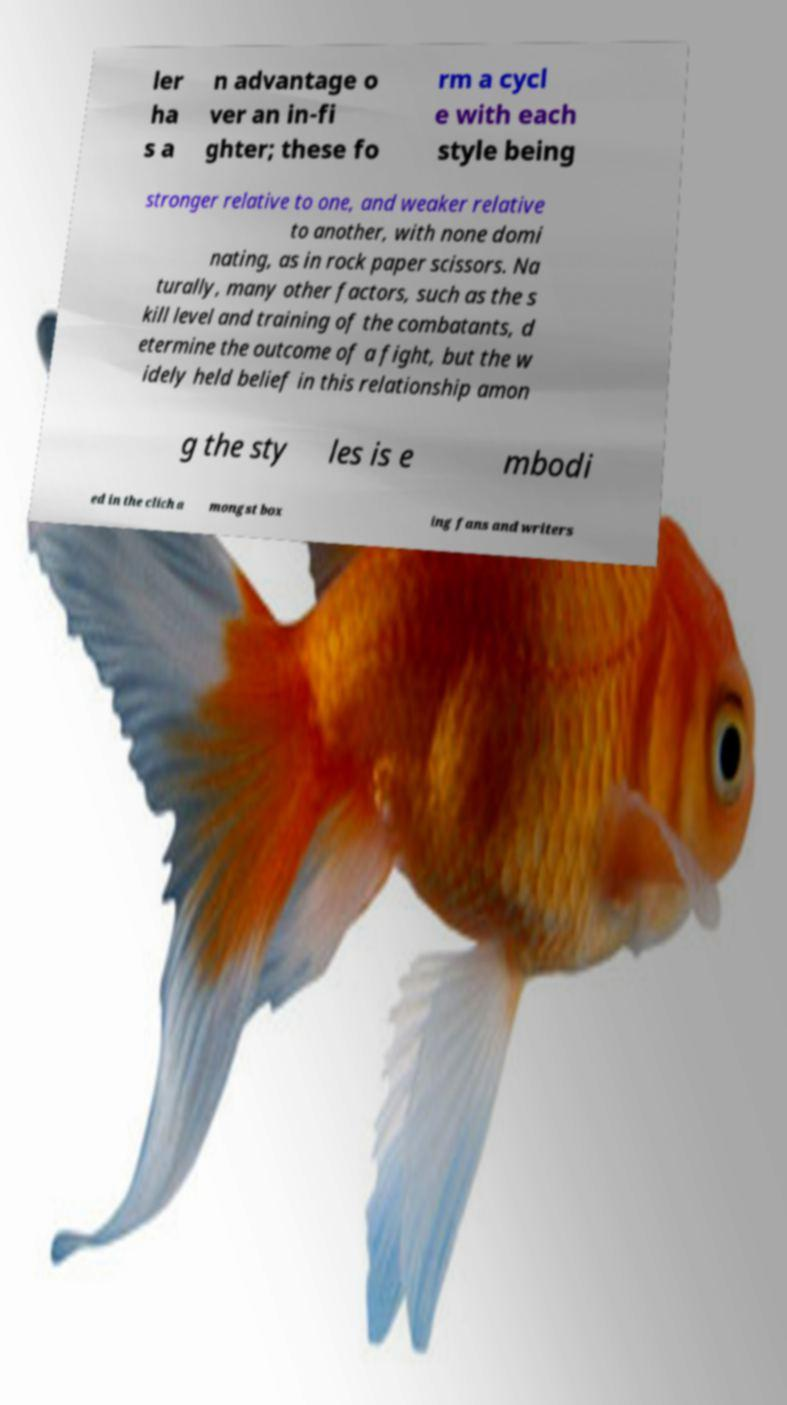There's text embedded in this image that I need extracted. Can you transcribe it verbatim? ler ha s a n advantage o ver an in-fi ghter; these fo rm a cycl e with each style being stronger relative to one, and weaker relative to another, with none domi nating, as in rock paper scissors. Na turally, many other factors, such as the s kill level and training of the combatants, d etermine the outcome of a fight, but the w idely held belief in this relationship amon g the sty les is e mbodi ed in the clich a mongst box ing fans and writers 